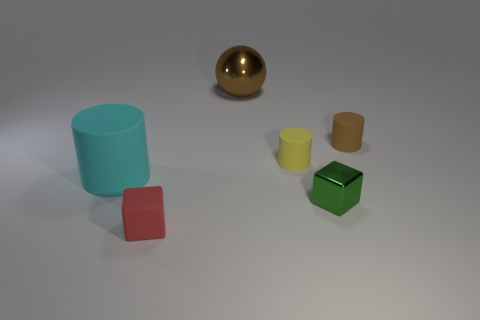There is a large sphere; is it the same color as the tiny matte object right of the tiny yellow rubber cylinder?
Your response must be concise. Yes. Are there any objects on the left side of the small green metallic cube?
Provide a short and direct response. Yes. There is a small matte object that is the same shape as the green metallic thing; what color is it?
Your response must be concise. Red. Is there any other thing that is the same shape as the brown metallic object?
Offer a terse response. No. What material is the brown sphere that is behind the tiny green thing?
Your answer should be very brief. Metal. There is a cyan rubber object that is the same shape as the tiny brown matte object; what size is it?
Give a very brief answer. Large. How many small cylinders have the same material as the small red object?
Offer a terse response. 2. How many blocks have the same color as the shiny ball?
Ensure brevity in your answer.  0. How many things are either objects to the right of the yellow rubber object or small things that are behind the green block?
Ensure brevity in your answer.  3. Are there fewer small red matte blocks right of the ball than small cyan rubber objects?
Make the answer very short. No. 